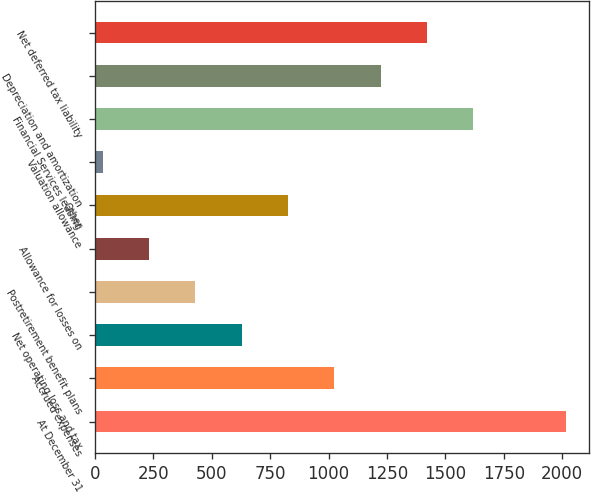<chart> <loc_0><loc_0><loc_500><loc_500><bar_chart><fcel>At December 31<fcel>Accrued expenses<fcel>Net operating loss and tax<fcel>Postretirement benefit plans<fcel>Allowance for losses on<fcel>Other<fcel>Valuation allowance<fcel>Financial Services leasing<fcel>Depreciation and amortization<fcel>Net deferred tax liability<nl><fcel>2015<fcel>1023.95<fcel>627.53<fcel>429.32<fcel>231.11<fcel>825.74<fcel>32.9<fcel>1618.58<fcel>1222.16<fcel>1420.37<nl></chart> 